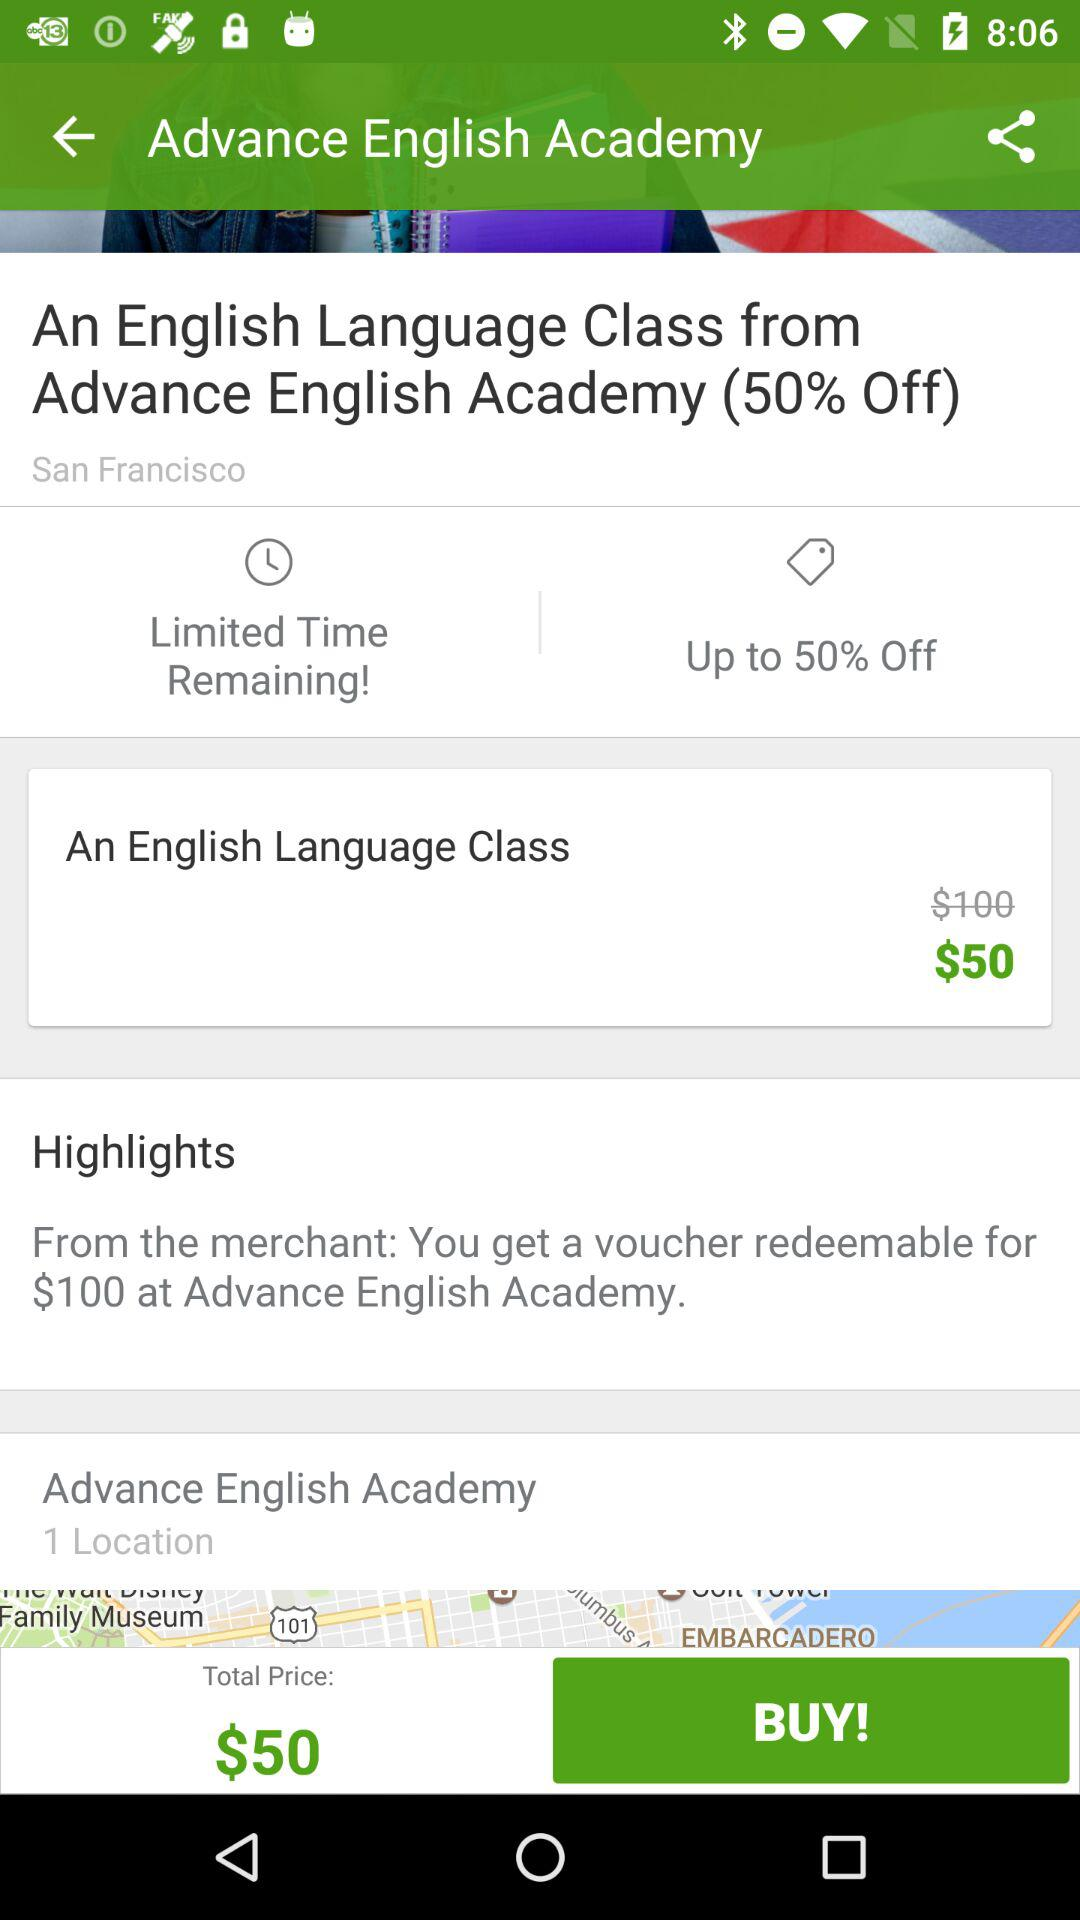How many locations does Advance English Academy have?
Answer the question using a single word or phrase. 1 